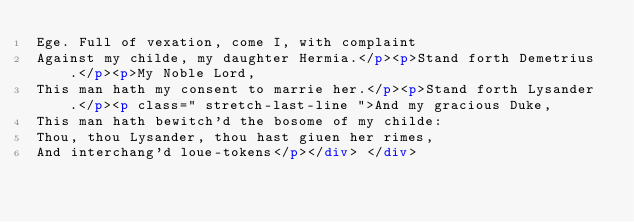<code> <loc_0><loc_0><loc_500><loc_500><_HTML_>Ege. Full of vexation, come I, with complaint
Against my childe, my daughter Hermia.</p><p>Stand forth Demetrius.</p><p>My Noble Lord,
This man hath my consent to marrie her.</p><p>Stand forth Lysander.</p><p class=" stretch-last-line ">And my gracious Duke,
This man hath bewitch'd the bosome of my childe:
Thou, thou Lysander, thou hast giuen her rimes,
And interchang'd loue-tokens</p></div> </div></code> 